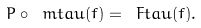<formula> <loc_0><loc_0><loc_500><loc_500>P \circ \ m t a u ( f ) = \ F t a u ( f ) .</formula> 